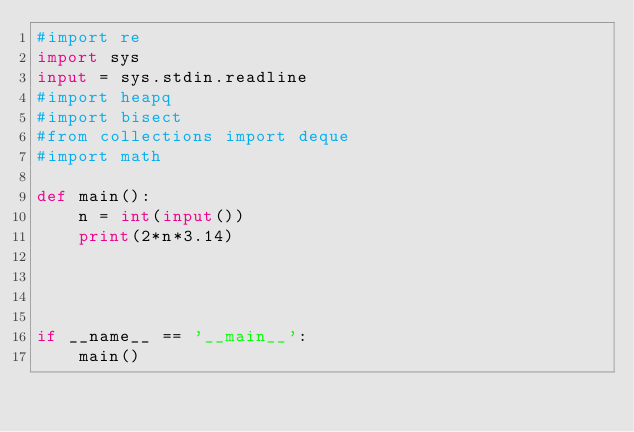Convert code to text. <code><loc_0><loc_0><loc_500><loc_500><_Python_>#import re
import sys
input = sys.stdin.readline
#import heapq
#import bisect
#from collections import deque
#import math

def main():
    n = int(input())
    print(2*n*3.14)
    


    
if __name__ == '__main__':
    main()
</code> 